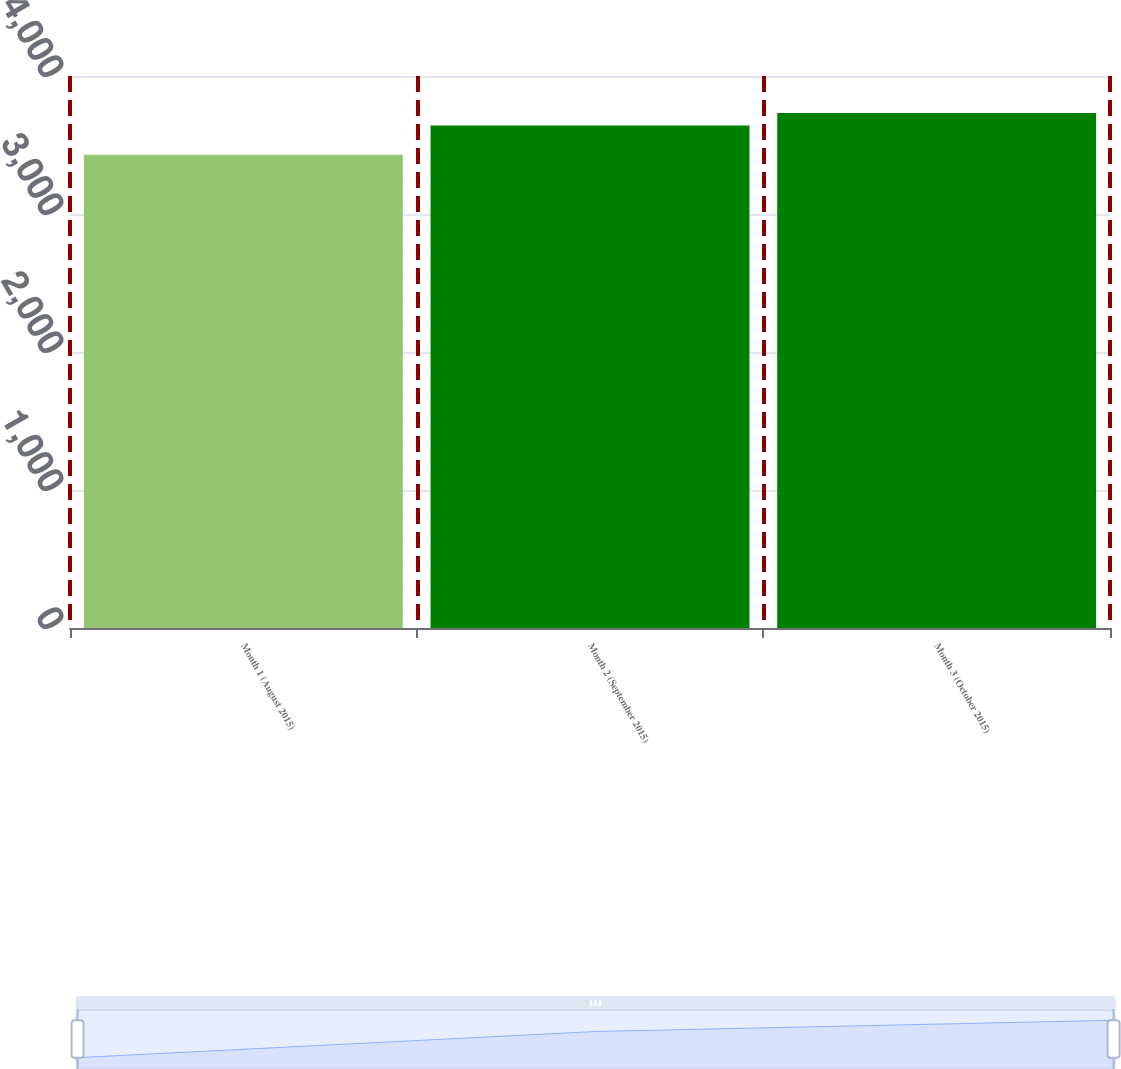Convert chart. <chart><loc_0><loc_0><loc_500><loc_500><bar_chart><fcel>Month 1 (August 2015)<fcel>Month 2 (September 2015)<fcel>Month 3 (October 2015)<nl><fcel>3429<fcel>3641<fcel>3732<nl></chart> 